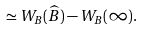Convert formula to latex. <formula><loc_0><loc_0><loc_500><loc_500>\simeq W _ { B } ( \widehat { B } ) - W _ { B } ( \infty ) .</formula> 